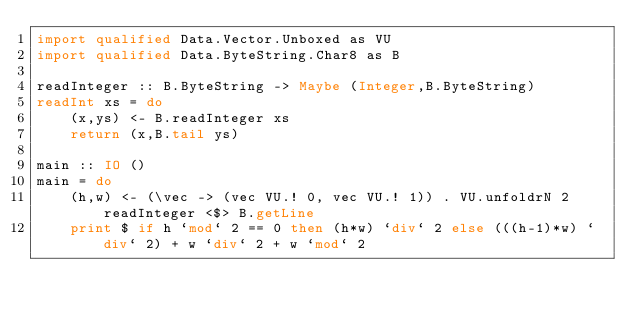Convert code to text. <code><loc_0><loc_0><loc_500><loc_500><_Haskell_>import qualified Data.Vector.Unboxed as VU
import qualified Data.ByteString.Char8 as B

readInteger :: B.ByteString -> Maybe (Integer,B.ByteString)
readInt xs = do
    (x,ys) <- B.readInteger xs
    return (x,B.tail ys)

main :: IO ()
main = do
    (h,w) <- (\vec -> (vec VU.! 0, vec VU.! 1)) . VU.unfoldrN 2 readInteger <$> B.getLine
    print $ if h `mod` 2 == 0 then (h*w) `div` 2 else (((h-1)*w) `div` 2) + w `div` 2 + w `mod` 2</code> 